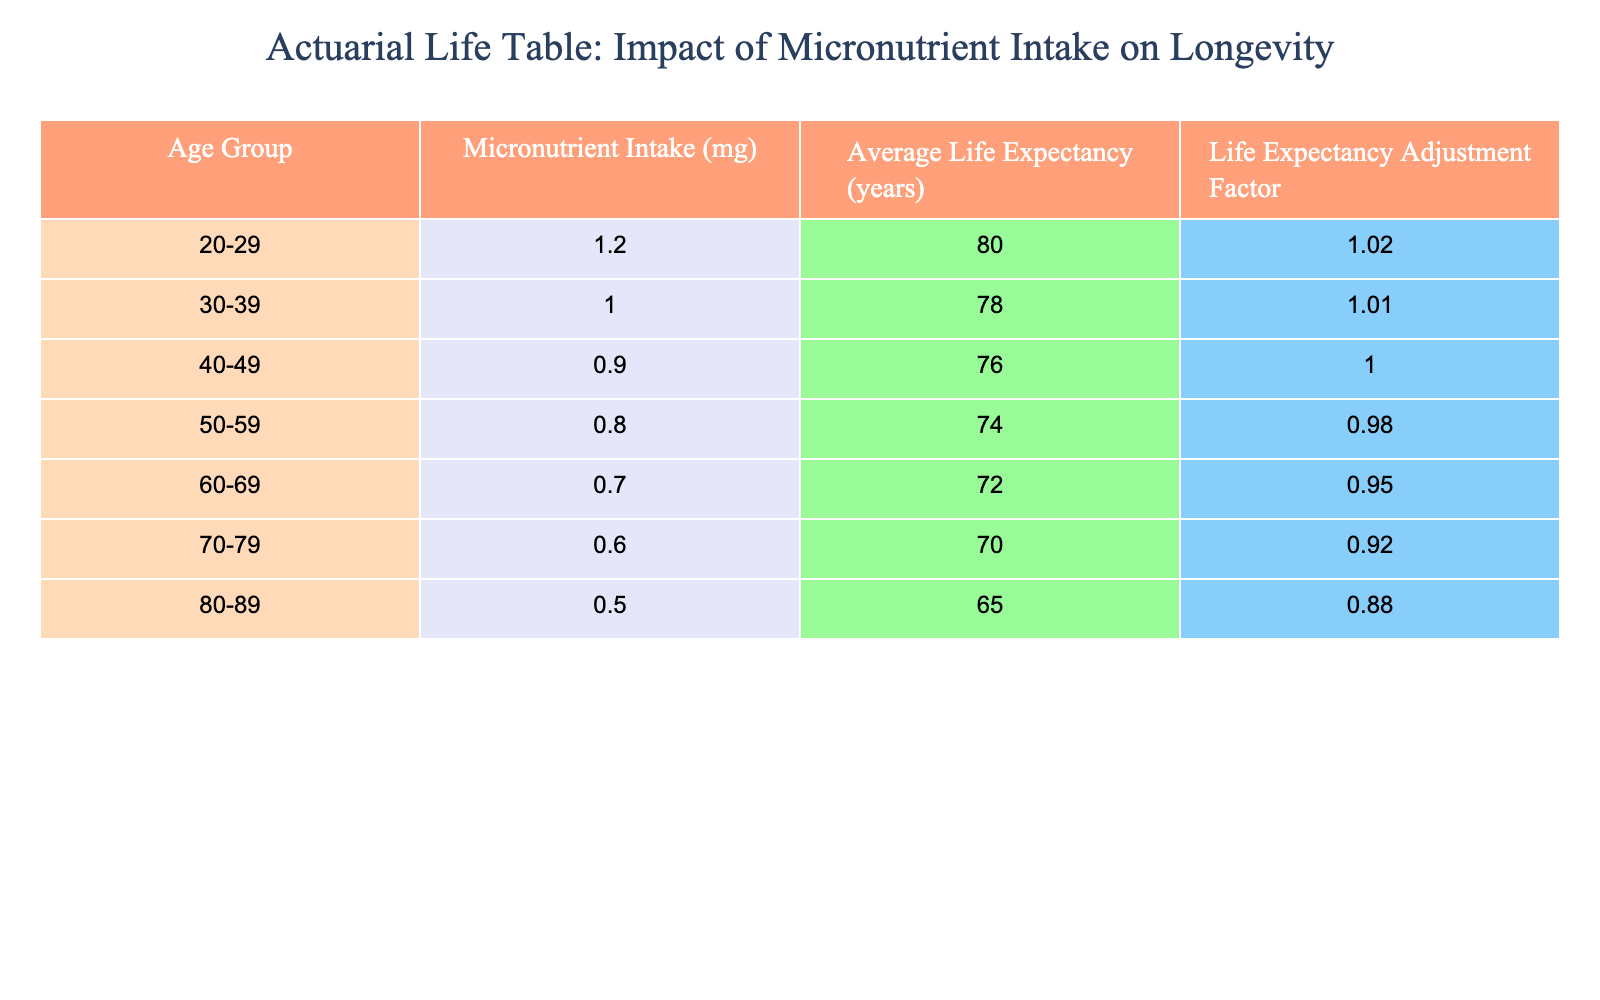What is the average life expectancy for the age group 40-49? The table shows that the average life expectancy for the age group 40-49 is listed under the "Average Life Expectancy" column as 76 years.
Answer: 76 How does the average life expectancy change from the age group 30-39 to 50-59? From the table, the average life expectancy for 30-39 is 78 years and for 50-59 is 74 years. The difference is 78 - 74 = 4 years, indicating a decrease of 4 years in average life expectancy.
Answer: 4 years decrease If an individual in the 60-69 age group increases their micronutrient intake from 0.7 mg to 1 mg, how will this affect their average life expectancy? Referring to the table, individuals aged 60-69 with a micronutrient intake of 0.7 mg have an average life expectancy of 72 years, while those in the 30-39 age group with an intake of 1.0 mg have an average life expectancy of 78 years. The increase in intake does not directly influence the average life expectancy for this age group, which remains at 72 years. Thus, it does not affect the average life expectancy as it is specific to age groups.
Answer: No change Is it true that individuals aged 80-89 have a higher life expectancy than those aged 70-79? The average life expectancy for the age group 80-89 is 65 years, whereas for 70-79 it is 70 years. Since 65 is less than 70, the statement is false.
Answer: No What is the average micronutrient intake across all age groups in the table? To find the average, sum the micronutrient intakes: 1.2 + 1.0 + 0.9 + 0.8 + 0.7 + 0.6 + 0.5 = 5.7 mg. There are 7 age groups, so dividing the total intake by 7 gives us an average of 5.7 / 7 = approximately 0.814 mg.
Answer: Approximately 0.814 mg If an individual is 30 years old and increases their micronutrient intake by 0.2 mg, what would their new intake be and how does this compare to the intake for individuals aged 40-49? The current intake for the 30-39 age group is 1.0 mg. After the increase of 0.2 mg, the new intake would be 1.0 + 0.2 = 1.2 mg. The intake for the 40-49 age group is 0.9 mg, which means the new intake (1.2 mg) is higher than the intake for the 40-49 age group.
Answer: New intake is 1.2 mg, higher than 0.9 mg How much does average life expectancy decrease for each decade after age 50? From the table: from 50-59 average life expectancy is 74 years, 60-69 is 72 years (decrease of 2 years), 70-79 is 70 years (another decrease of 2 years), and 80-89 is 65 years (decrease of 5 years). The average decrease per decade from 50 onward is (2 + 2 + 5) / 3 = approximately 3 years per decade.
Answer: Approximately 3 years per decade Is there a trend indicating that lower micronutrient intake leads to shorter life expectancy? Analyzing the table, as the micronutrient intake decreases across the age groups, the average life expectancy also decreases. For instance, from 1.2 mg at age 20-29 leading to 80 years life expectancy, down to 0.5 mg at age 80-89 leading to 65 years. This suggests a negative correlation between micronutrient intake and life expectancy, indicating that lower intake does lead to shorter life expectancy.
Answer: Yes 